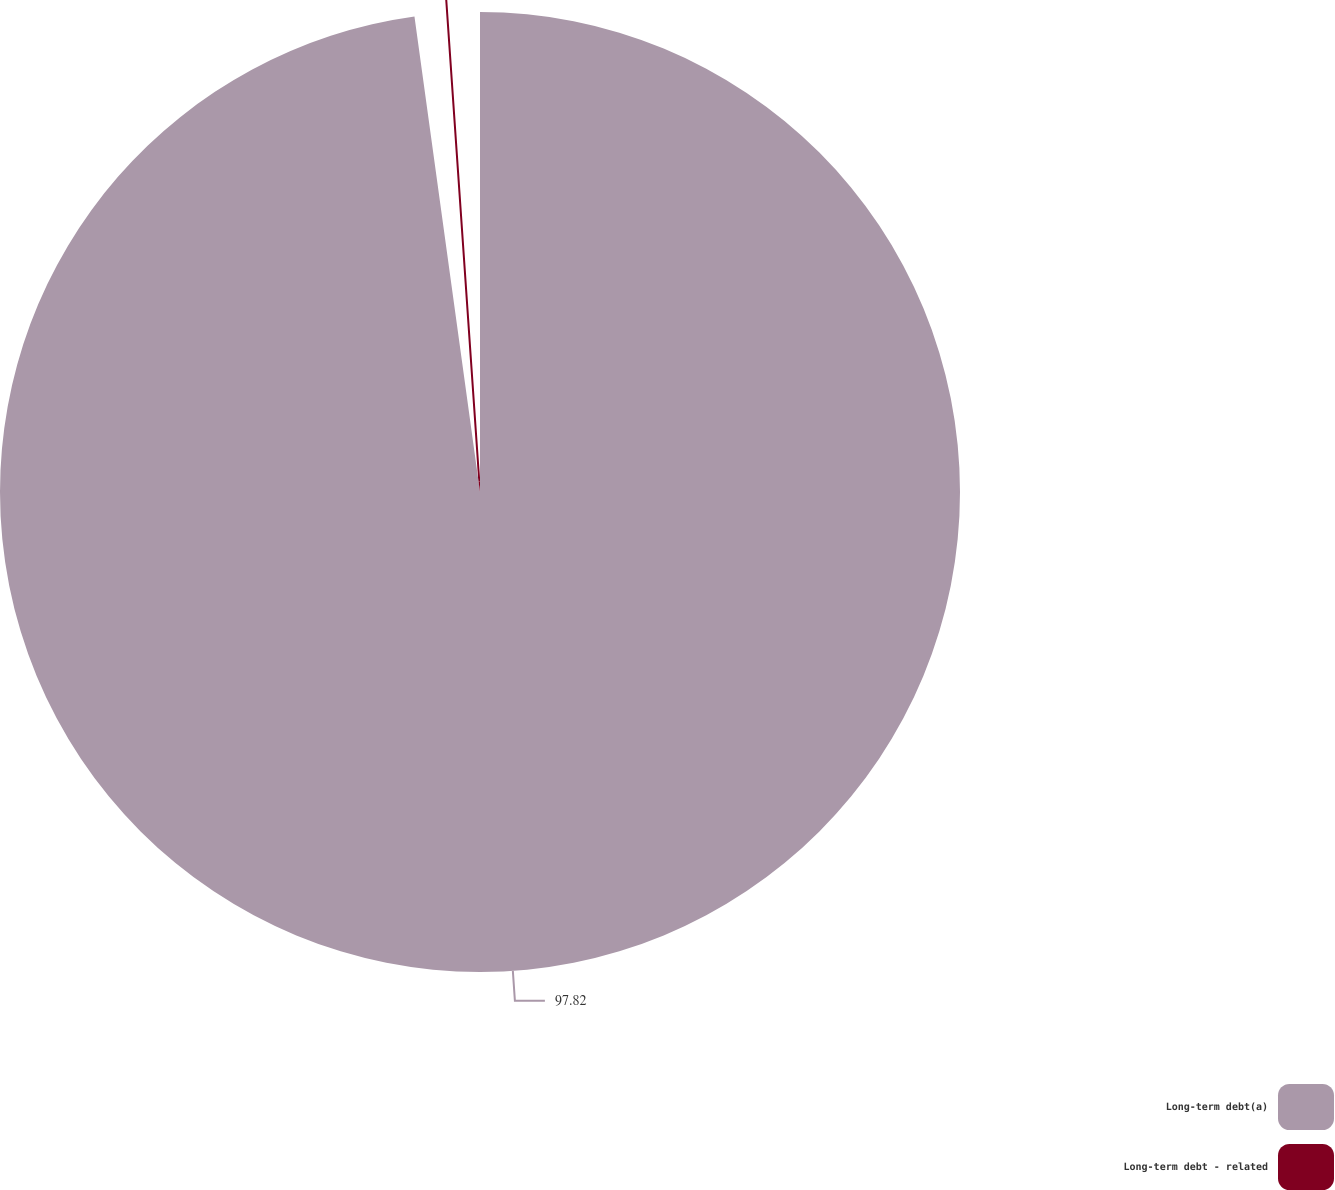Convert chart. <chart><loc_0><loc_0><loc_500><loc_500><pie_chart><fcel>Long-term debt(a)<fcel>Long-term debt - related<nl><fcel>97.82%<fcel>2.18%<nl></chart> 